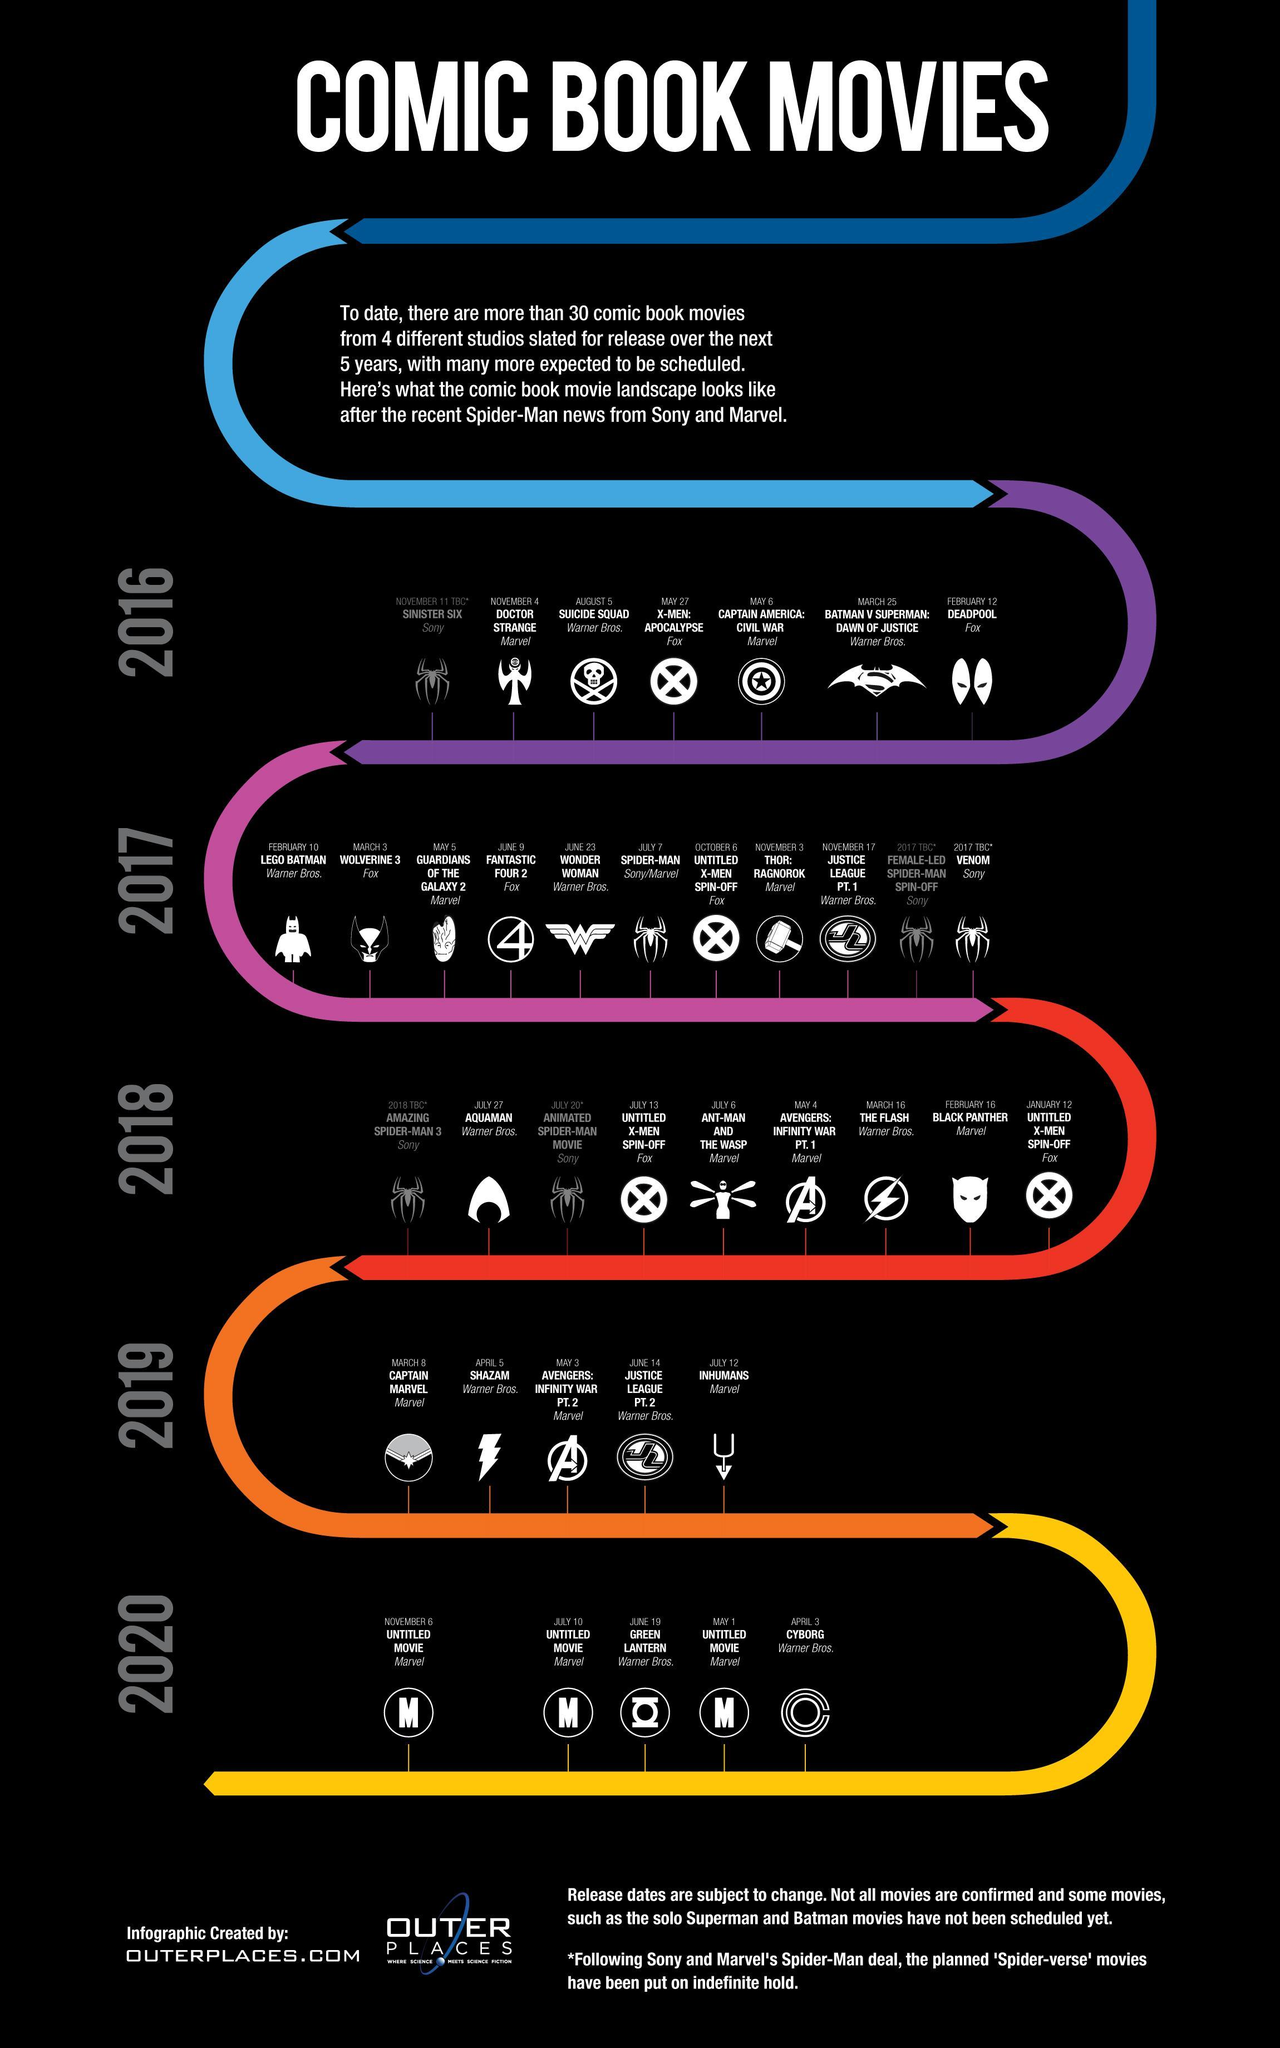How many Marvel movies were scheduled to be released in 2020?
Answer the question with a short phrase. 3 How many comic books of based movies produced by Fox were scheduled for publishing in 2016? 2 